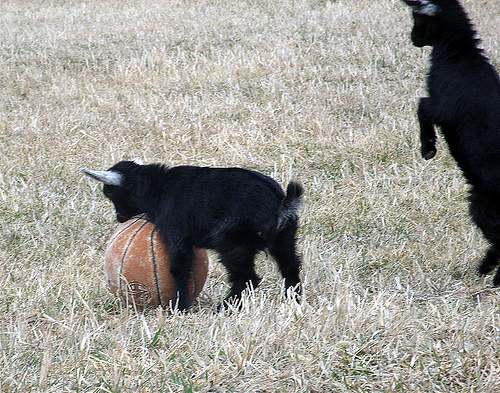<image>
Is the goat on the basketball? Yes. Looking at the image, I can see the goat is positioned on top of the basketball, with the basketball providing support. Is the animal behind the ball? No. The animal is not behind the ball. From this viewpoint, the animal appears to be positioned elsewhere in the scene. Is there a goat next to the goat? Yes. The goat is positioned adjacent to the goat, located nearby in the same general area. 